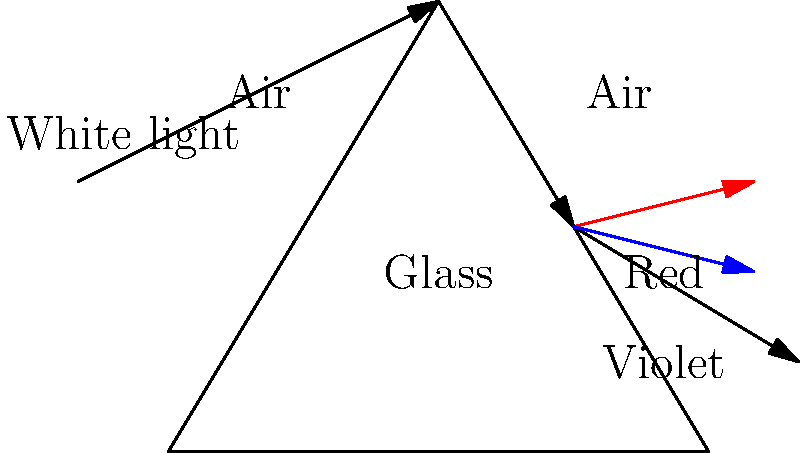In your latest historical fiction novel set in the Caribbean, you're describing a scene where your protagonist observes a vibrant rainbow after a tropical storm. To accurately portray this natural phenomenon, you need to understand the physics behind it. Using the diagram provided, explain how white light is separated into its component colors when passing through a prism, and why this process is similar to rainbow formation. What physical property of light causes the separation of colors, and how does this relate to the refractive index of the medium? To understand the formation of rainbows and the separation of white light into its component colors, we need to consider the following steps:

1. Refraction: When light enters a medium with a different refractive index (in this case, from air to glass), it bends or refracts. The amount of bending depends on the refractive index of the medium and the wavelength of light.

2. Dispersion: White light is composed of different wavelengths, each corresponding to a different color. When white light enters the prism, each wavelength bends at a slightly different angle due to dispersion.

3. Wavelength dependence: The refractive index of a medium depends on the wavelength of light. Generally, shorter wavelengths (violet) bend more than longer wavelengths (red).

4. Separation of colors: As the light exits the prism back into air, it refracts again, further separating the colors. This results in the familiar rainbow spectrum.

5. Rainbow formation: In a real rainbow, water droplets act like tiny prisms. Sunlight enters a droplet, reflects off the back, and then exits, separating into different colors due to dispersion.

The physical property causing color separation is dispersion, which is a consequence of the wavelength-dependent refractive index. The refractive index ($n$) is related to the speed of light in a medium:

$$ n = \frac{c}{v} $$

where $c$ is the speed of light in vacuum and $v$ is the speed of light in the medium.

Different wavelengths travel at slightly different speeds in a medium, leading to different refractive indices and, consequently, different angles of refraction. This phenomenon is described by Snell's law:

$$ n_1 \sin(\theta_1) = n_2 \sin(\theta_2) $$

where $n_1$ and $n_2$ are the refractive indices of the two media, and $\theta_1$ and $\theta_2$ are the angles of incidence and refraction, respectively.

In both prisms and rainbows, this wavelength-dependent refraction causes the separation of white light into its component colors, creating the beautiful spectrum we observe.
Answer: Dispersion due to wavelength-dependent refractive index 